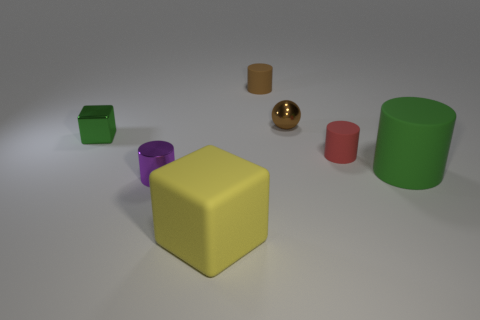There is a block behind the large rubber block; is its color the same as the large block?
Make the answer very short. No. How big is the thing that is to the left of the small ball and behind the small block?
Your answer should be compact. Small. How many large objects are yellow rubber cubes or green rubber cylinders?
Your answer should be compact. 2. There is a green thing that is behind the small red matte cylinder; what shape is it?
Provide a succinct answer. Cube. What number of small brown cylinders are there?
Give a very brief answer. 1. Do the purple cylinder and the big yellow block have the same material?
Your answer should be very brief. No. Is the number of green metal blocks behind the brown rubber object greater than the number of tiny purple metal cylinders?
Provide a succinct answer. No. How many things are matte blocks or cubes to the right of the small purple cylinder?
Your answer should be compact. 1. Is the number of things behind the ball greater than the number of green shiny things in front of the tiny red cylinder?
Make the answer very short. Yes. There is a green object to the right of the brown thing in front of the tiny matte cylinder behind the shiny block; what is it made of?
Your response must be concise. Rubber. 